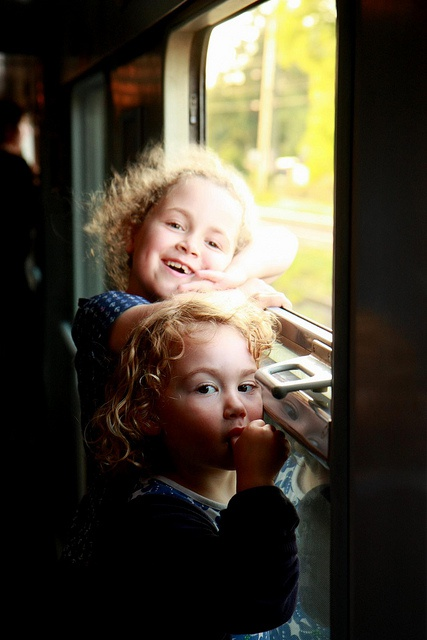Describe the objects in this image and their specific colors. I can see people in black, maroon, ivory, and gray tones and people in black, ivory, tan, and maroon tones in this image. 